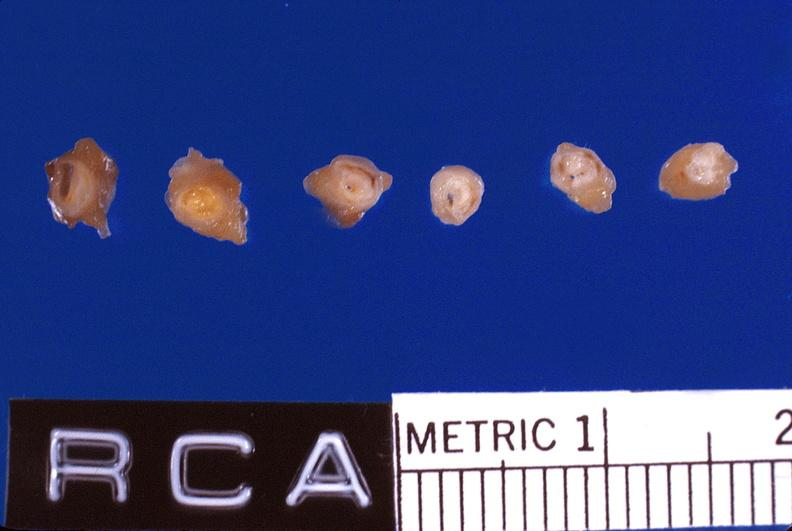s lesion of myocytolysis present?
Answer the question using a single word or phrase. No 